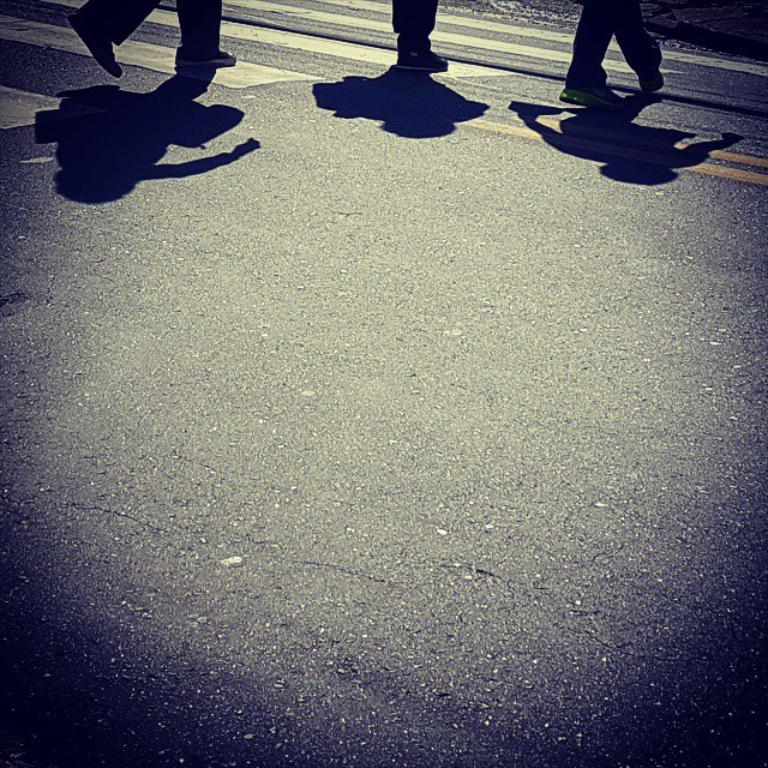How many people are represented by the legs and shadows in the image? There are legs and shadows of three persons in the image. What is the main setting or location depicted in the image? The image depicts a road. What type of agreement was reached at the table in the image? There is no table present in the image, and therefore no agreement can be reached at a table. 